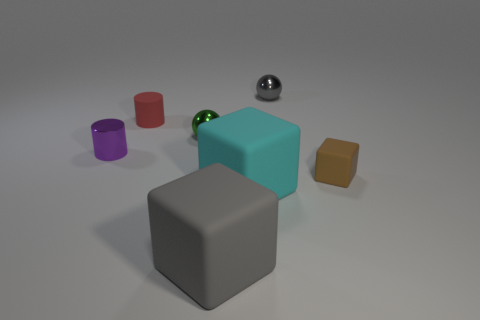Add 1 small green spheres. How many objects exist? 8 Subtract all balls. How many objects are left? 5 Subtract 0 purple balls. How many objects are left? 7 Subtract all small gray rubber blocks. Subtract all small red matte objects. How many objects are left? 6 Add 7 purple shiny objects. How many purple shiny objects are left? 8 Add 3 brown things. How many brown things exist? 4 